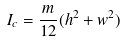Convert formula to latex. <formula><loc_0><loc_0><loc_500><loc_500>I _ { c } = \frac { m } { 1 2 } ( h ^ { 2 } + w ^ { 2 } )</formula> 